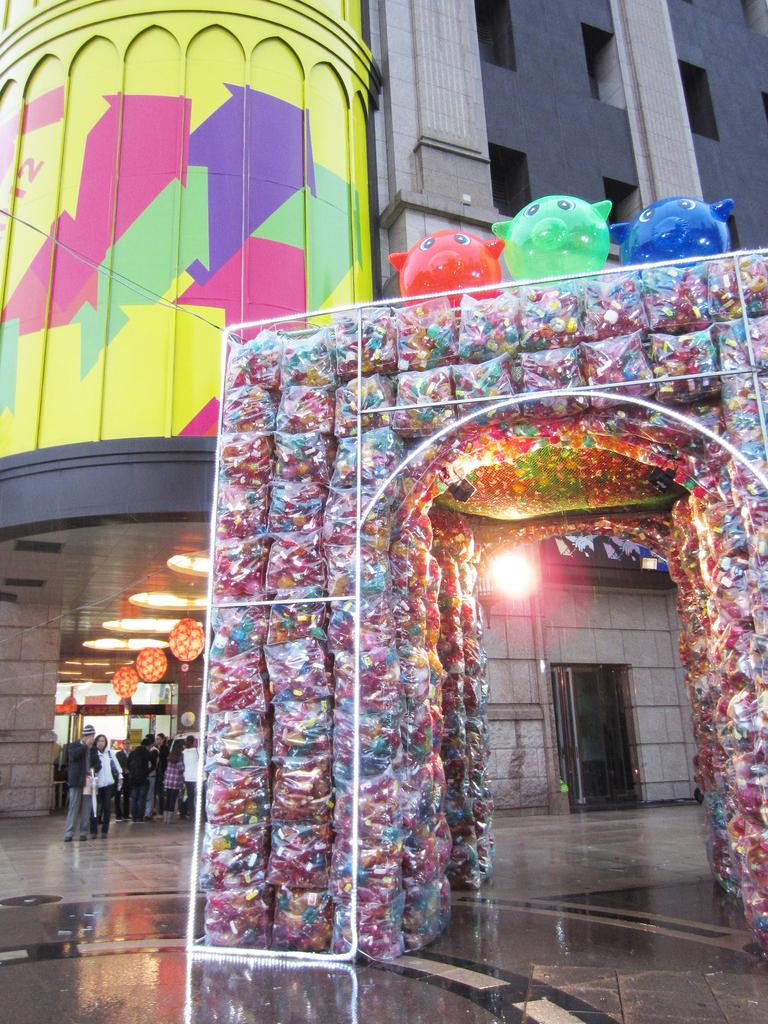What type of structures are present in the image? There are buildings in the image. What can be seen at the bottom of the buildings? There are lights and balloons at the bottom of the buildings. Are there any people visible in the image? Yes, there are people standing on the floor in the image. What type of meeting is taking place at the border in the image? There is no meeting or border present in the image; it features buildings with lights and balloons at the bottom and people standing on the floor. 